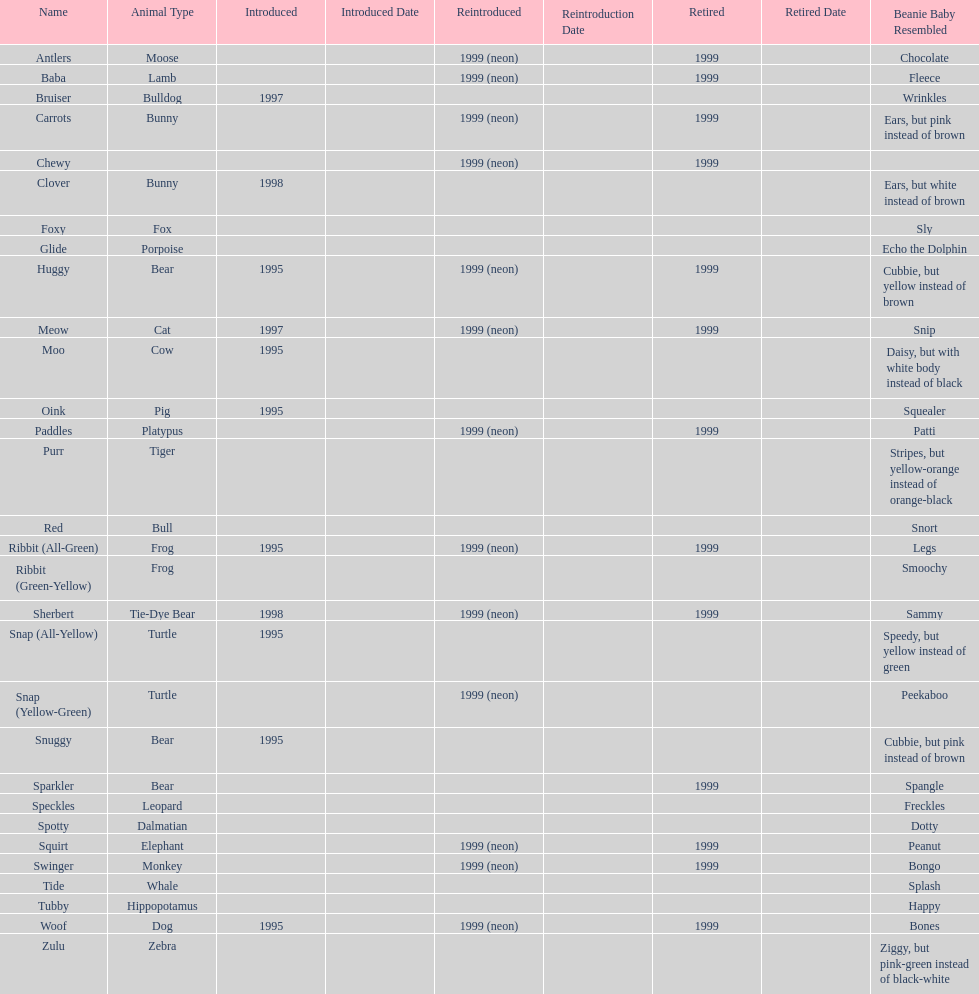Tell me the number of pillow pals reintroduced in 1999. 13. 